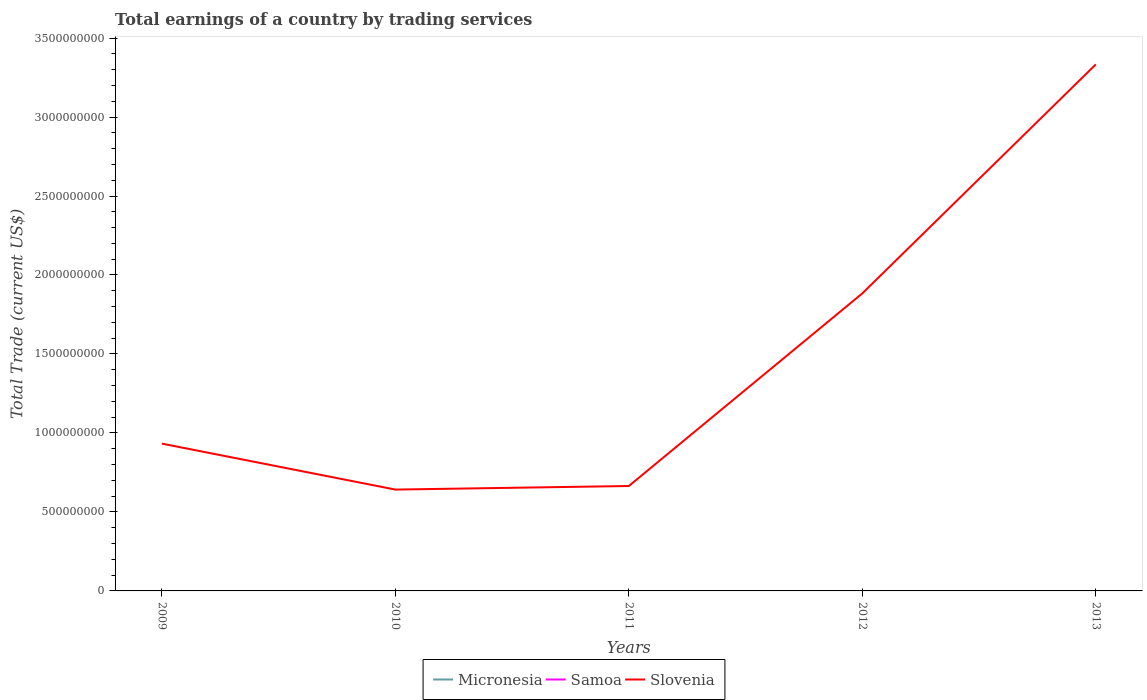How many different coloured lines are there?
Make the answer very short. 1. Across all years, what is the maximum total earnings in Slovenia?
Offer a very short reply. 6.42e+08. What is the total total earnings in Slovenia in the graph?
Provide a succinct answer. -1.24e+09. What is the difference between the highest and the second highest total earnings in Slovenia?
Your answer should be very brief. 2.69e+09. Is the total earnings in Micronesia strictly greater than the total earnings in Slovenia over the years?
Your response must be concise. Yes. What is the difference between two consecutive major ticks on the Y-axis?
Keep it short and to the point. 5.00e+08. Does the graph contain grids?
Offer a terse response. No. Where does the legend appear in the graph?
Provide a short and direct response. Bottom center. How are the legend labels stacked?
Give a very brief answer. Horizontal. What is the title of the graph?
Your answer should be very brief. Total earnings of a country by trading services. Does "Low & middle income" appear as one of the legend labels in the graph?
Offer a very short reply. No. What is the label or title of the X-axis?
Keep it short and to the point. Years. What is the label or title of the Y-axis?
Your answer should be compact. Total Trade (current US$). What is the Total Trade (current US$) of Slovenia in 2009?
Offer a very short reply. 9.32e+08. What is the Total Trade (current US$) of Micronesia in 2010?
Provide a succinct answer. 0. What is the Total Trade (current US$) in Slovenia in 2010?
Keep it short and to the point. 6.42e+08. What is the Total Trade (current US$) of Slovenia in 2011?
Make the answer very short. 6.64e+08. What is the Total Trade (current US$) in Samoa in 2012?
Offer a terse response. 0. What is the Total Trade (current US$) in Slovenia in 2012?
Make the answer very short. 1.88e+09. What is the Total Trade (current US$) in Slovenia in 2013?
Provide a succinct answer. 3.33e+09. Across all years, what is the maximum Total Trade (current US$) of Slovenia?
Give a very brief answer. 3.33e+09. Across all years, what is the minimum Total Trade (current US$) in Slovenia?
Your answer should be very brief. 6.42e+08. What is the total Total Trade (current US$) in Samoa in the graph?
Provide a succinct answer. 0. What is the total Total Trade (current US$) of Slovenia in the graph?
Offer a very short reply. 7.45e+09. What is the difference between the Total Trade (current US$) of Slovenia in 2009 and that in 2010?
Offer a very short reply. 2.91e+08. What is the difference between the Total Trade (current US$) in Slovenia in 2009 and that in 2011?
Your response must be concise. 2.68e+08. What is the difference between the Total Trade (current US$) of Slovenia in 2009 and that in 2012?
Your response must be concise. -9.51e+08. What is the difference between the Total Trade (current US$) in Slovenia in 2009 and that in 2013?
Offer a terse response. -2.40e+09. What is the difference between the Total Trade (current US$) in Slovenia in 2010 and that in 2011?
Ensure brevity in your answer.  -2.27e+07. What is the difference between the Total Trade (current US$) in Slovenia in 2010 and that in 2012?
Provide a short and direct response. -1.24e+09. What is the difference between the Total Trade (current US$) in Slovenia in 2010 and that in 2013?
Your answer should be very brief. -2.69e+09. What is the difference between the Total Trade (current US$) of Slovenia in 2011 and that in 2012?
Make the answer very short. -1.22e+09. What is the difference between the Total Trade (current US$) in Slovenia in 2011 and that in 2013?
Your response must be concise. -2.67e+09. What is the difference between the Total Trade (current US$) of Slovenia in 2012 and that in 2013?
Provide a short and direct response. -1.45e+09. What is the average Total Trade (current US$) in Micronesia per year?
Offer a terse response. 0. What is the average Total Trade (current US$) of Slovenia per year?
Offer a very short reply. 1.49e+09. What is the ratio of the Total Trade (current US$) in Slovenia in 2009 to that in 2010?
Your response must be concise. 1.45. What is the ratio of the Total Trade (current US$) in Slovenia in 2009 to that in 2011?
Make the answer very short. 1.4. What is the ratio of the Total Trade (current US$) of Slovenia in 2009 to that in 2012?
Offer a terse response. 0.5. What is the ratio of the Total Trade (current US$) of Slovenia in 2009 to that in 2013?
Your answer should be compact. 0.28. What is the ratio of the Total Trade (current US$) of Slovenia in 2010 to that in 2011?
Provide a succinct answer. 0.97. What is the ratio of the Total Trade (current US$) in Slovenia in 2010 to that in 2012?
Keep it short and to the point. 0.34. What is the ratio of the Total Trade (current US$) in Slovenia in 2010 to that in 2013?
Make the answer very short. 0.19. What is the ratio of the Total Trade (current US$) of Slovenia in 2011 to that in 2012?
Offer a terse response. 0.35. What is the ratio of the Total Trade (current US$) in Slovenia in 2011 to that in 2013?
Provide a succinct answer. 0.2. What is the ratio of the Total Trade (current US$) of Slovenia in 2012 to that in 2013?
Keep it short and to the point. 0.57. What is the difference between the highest and the second highest Total Trade (current US$) in Slovenia?
Ensure brevity in your answer.  1.45e+09. What is the difference between the highest and the lowest Total Trade (current US$) in Slovenia?
Ensure brevity in your answer.  2.69e+09. 